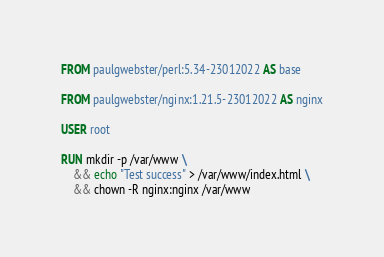<code> <loc_0><loc_0><loc_500><loc_500><_Dockerfile_>FROM paulgwebster/perl:5.34-23012022 AS base

FROM paulgwebster/nginx:1.21.5-23012022 AS nginx

USER root

RUN mkdir -p /var/www \
    && echo "Test success" > /var/www/index.html \
    && chown -R nginx:nginx /var/www
</code> 